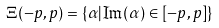Convert formula to latex. <formula><loc_0><loc_0><loc_500><loc_500>\Xi ( - p , p ) = \{ \alpha | \Im ( \alpha ) \in [ - p , p ] \}</formula> 